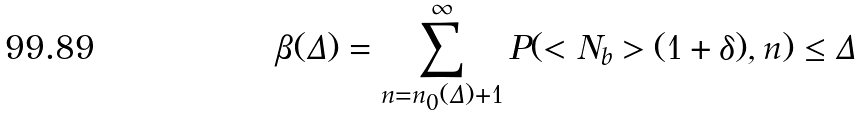Convert formula to latex. <formula><loc_0><loc_0><loc_500><loc_500>\beta ( \Delta ) = \sum ^ { \infty } _ { n = n _ { 0 } ( { \Delta } ) + 1 } P ( < N _ { b } > ( 1 + \delta ) , n ) \leq \Delta</formula> 